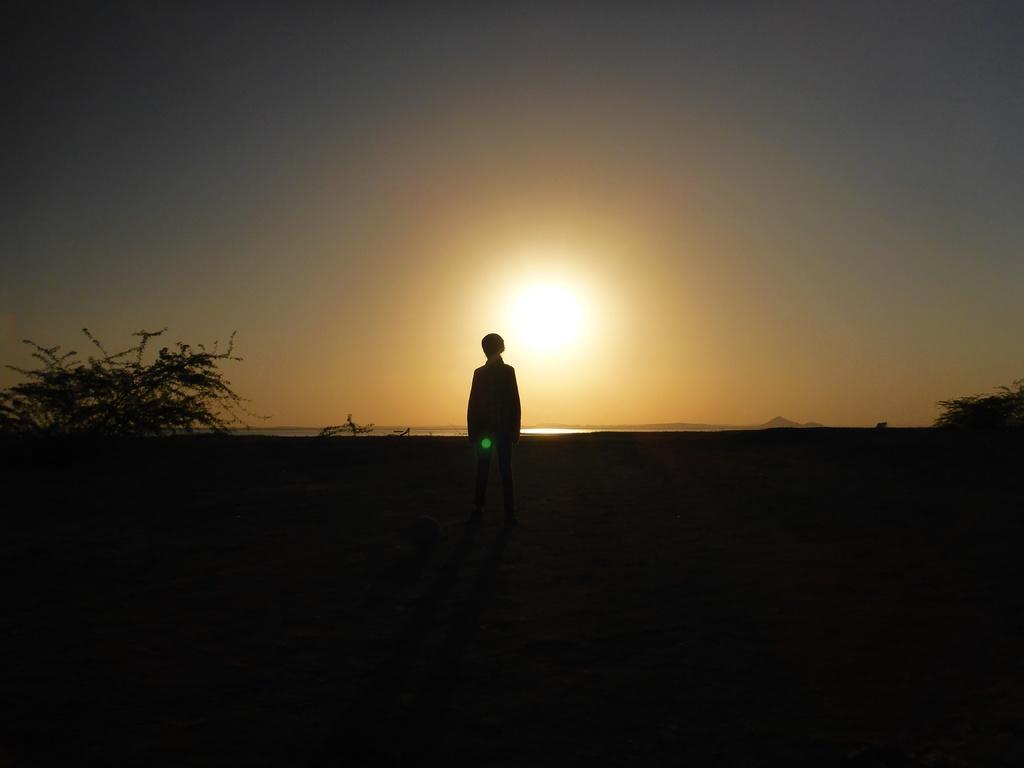Could you give a brief overview of what you see in this image? In this image there is a person standing. On the right and left side of the image is a tree. In the background there is the sky. The bottom of the image is dark. 